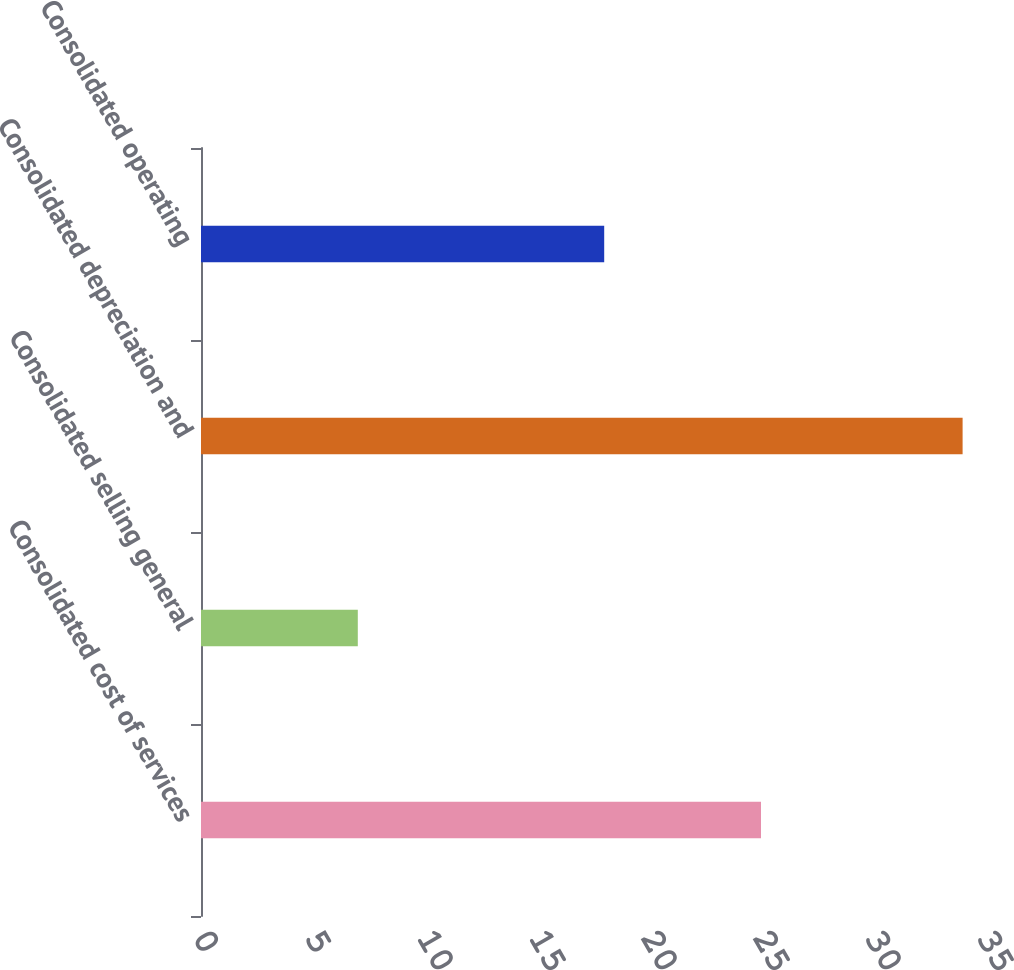Convert chart. <chart><loc_0><loc_0><loc_500><loc_500><bar_chart><fcel>Consolidated cost of services<fcel>Consolidated selling general<fcel>Consolidated depreciation and<fcel>Consolidated operating<nl><fcel>25<fcel>7<fcel>34<fcel>18<nl></chart> 